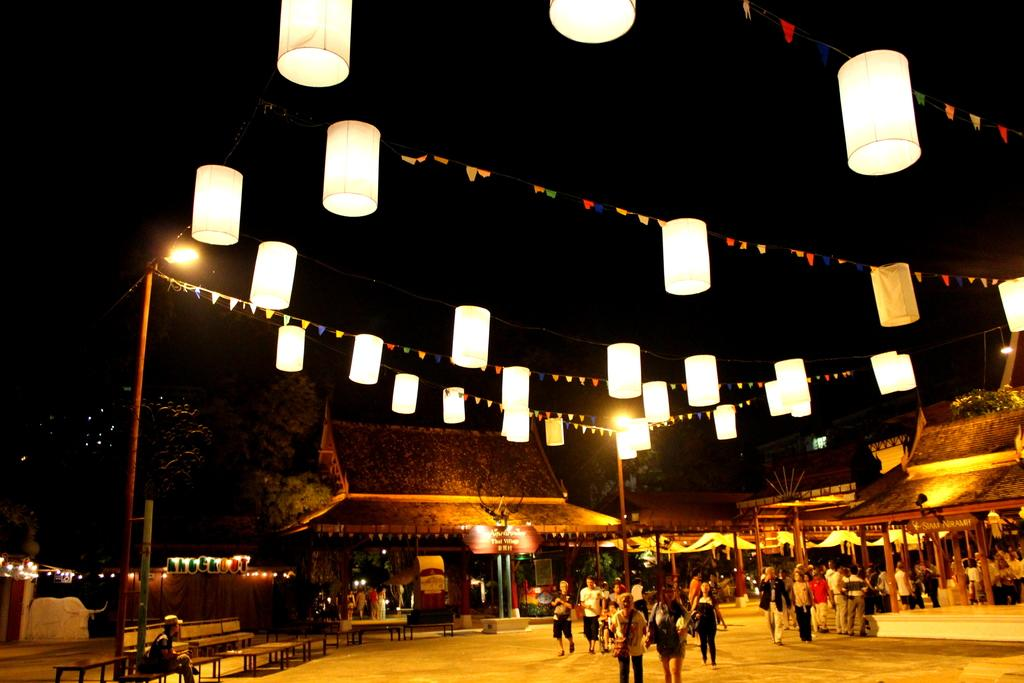What are the people in the image doing? The people in the image are walking on the ground. What type of structures can be seen in the image? There are sheds in the image. What type of seating is available in the image? There are benches in the image. What type of vegetation is present in the image? There are trees in the image. What type of lighting is present in the image? There are lights on ropes in the image. What type of wine is being served in the image? There is no wine present in the image. Are the people wearing mittens in the image? There is no mention of mittens or any clothing items in the image. 